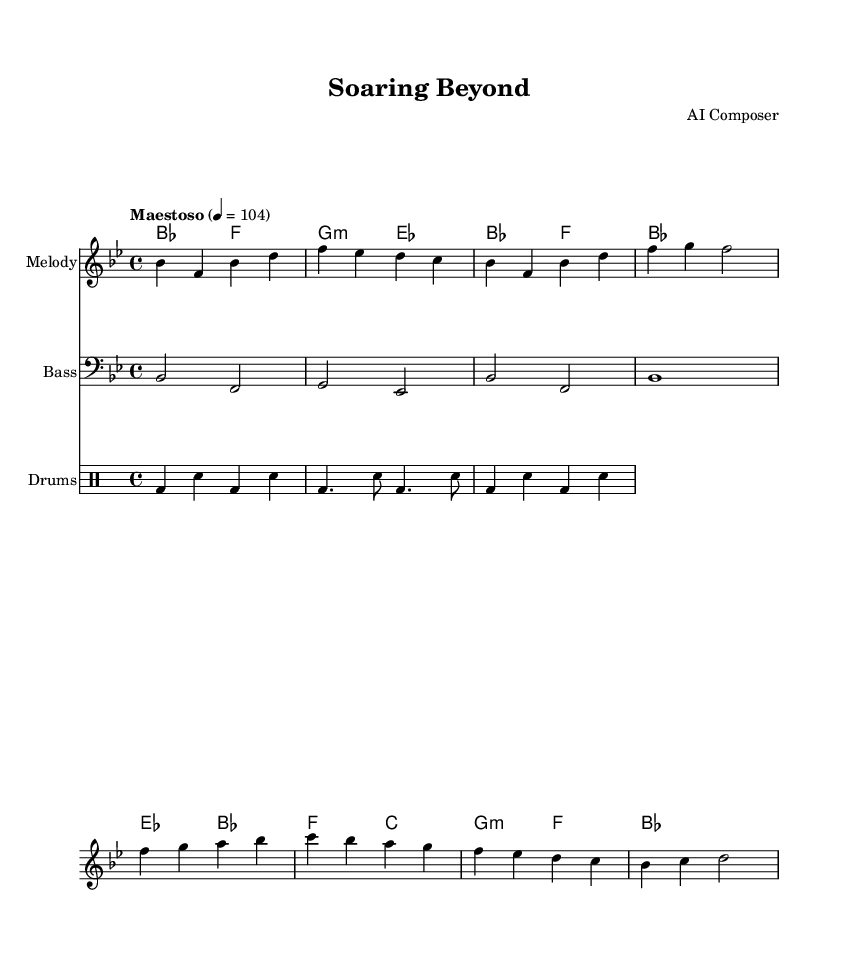What is the key signature of this music? The key signature is determined by the number of sharps or flats indicated at the beginning of the staff. In this sheet music, the key signature shows two flats (B flat and E flat) which indicates that it is in B flat major.
Answer: B flat major What is the time signature of this composition? The time signature appears at the beginning of the music and indicates the number of beats in each measure. In this case, it is shown as 4/4, which means there are four beats per measure and the quarter note gets one beat.
Answer: 4/4 What is the tempo marking for this piece? The tempo marking, which indicates the speed of the piece, is given at the beginning beside the time signature. It says "Maestoso" with a metronome marking of 104, meaning it should be played in a stately manner at a speed of 104 beats per minute.
Answer: Maestoso 4 = 104 How many main themes are present in the melody? By analyzing the structure of the melody section, it is evident that there are two distinct main themes labeled as A and B. Each theme consists of unique melodic phrases that set them apart from each other.
Answer: Two What is the role of the bass line in this score? The bass line typically provides harmonic foundation and depth to the overall composition. In the provided sheet music, the bass notes match the chords indicated in the chord symbols above, anchoring the harmonic progression and complementing the melody.
Answer: Harmonic foundation Which instrument is labeled for the drum part? The drum part is specified under the staff labeled as 'Drums', which indicates that this section contains the percussion instruments for the piece, specifically the bass drum and snare drum as referenced in the drummode code.
Answer: Drums What is the general mood expressed by this soundtrack? The soundtrack is inherently designed to evoke heroism and inspiration, as indicated by the choice of tempo (Maestoso), the majestic harmonic progressions, and the overall structure and themes that convey strength and optimism.
Answer: Heroic and inspirational 